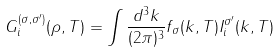Convert formula to latex. <formula><loc_0><loc_0><loc_500><loc_500>G _ { i } ^ { ( \sigma , \sigma ^ { \prime } ) } ( \rho , T ) = \int \frac { d ^ { 3 } k } { ( 2 \pi ) ^ { 3 } } f _ { \sigma } ( k , T ) I _ { i } ^ { \sigma ^ { \prime } } ( k , T )</formula> 